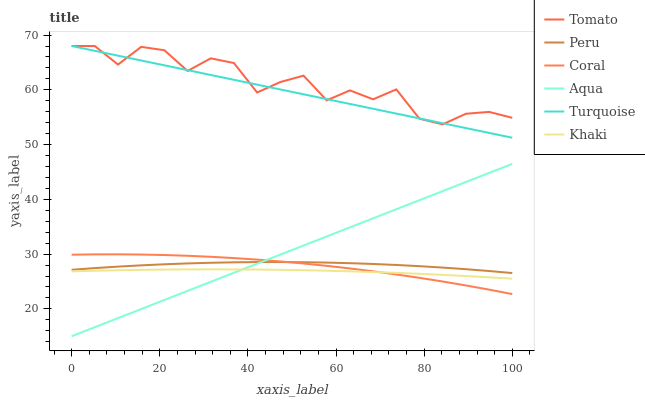Does Khaki have the minimum area under the curve?
Answer yes or no. Yes. Does Tomato have the maximum area under the curve?
Answer yes or no. Yes. Does Turquoise have the minimum area under the curve?
Answer yes or no. No. Does Turquoise have the maximum area under the curve?
Answer yes or no. No. Is Turquoise the smoothest?
Answer yes or no. Yes. Is Tomato the roughest?
Answer yes or no. Yes. Is Khaki the smoothest?
Answer yes or no. No. Is Khaki the roughest?
Answer yes or no. No. Does Aqua have the lowest value?
Answer yes or no. Yes. Does Turquoise have the lowest value?
Answer yes or no. No. Does Turquoise have the highest value?
Answer yes or no. Yes. Does Khaki have the highest value?
Answer yes or no. No. Is Coral less than Tomato?
Answer yes or no. Yes. Is Turquoise greater than Aqua?
Answer yes or no. Yes. Does Coral intersect Aqua?
Answer yes or no. Yes. Is Coral less than Aqua?
Answer yes or no. No. Is Coral greater than Aqua?
Answer yes or no. No. Does Coral intersect Tomato?
Answer yes or no. No. 